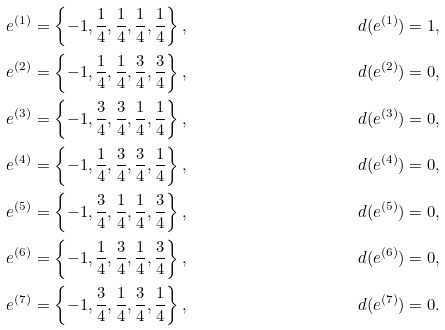<formula> <loc_0><loc_0><loc_500><loc_500>e ^ { ( 1 ) } & = \left \{ - 1 , \frac { 1 } { 4 } , \frac { 1 } { 4 } , \frac { 1 } { 4 } , \frac { 1 } { 4 } \right \} , & d ( e ^ { ( 1 ) } ) = 1 , & & \\ e ^ { ( 2 ) } & = \left \{ - 1 , \frac { 1 } { 4 } , \frac { 1 } { 4 } , \frac { 3 } { 4 } , \frac { 3 } { 4 } \right \} , & d ( e ^ { ( 2 ) } ) = 0 , & & \\ e ^ { ( 3 ) } & = \left \{ - 1 , \frac { 3 } { 4 } , \frac { 3 } { 4 } , \frac { 1 } { 4 } , \frac { 1 } { 4 } \right \} , & d ( e ^ { ( 3 ) } ) = 0 , & & \\ e ^ { ( 4 ) } & = \left \{ - 1 , \frac { 1 } { 4 } , \frac { 3 } { 4 } , \frac { 3 } { 4 } , \frac { 1 } { 4 } \right \} , & d ( e ^ { ( 4 ) } ) = 0 , & & \\ e ^ { ( 5 ) } & = \left \{ - 1 , \frac { 3 } { 4 } , \frac { 1 } { 4 } , \frac { 1 } { 4 } , \frac { 3 } { 4 } \right \} , & d ( e ^ { ( 5 ) } ) = 0 , & & \\ e ^ { ( 6 ) } & = \left \{ - 1 , \frac { 1 } { 4 } , \frac { 3 } { 4 } , \frac { 1 } { 4 } , \frac { 3 } { 4 } \right \} , & d ( e ^ { ( 6 ) } ) = 0 , & & \\ e ^ { ( 7 ) } & = \left \{ - 1 , \frac { 3 } { 4 } , \frac { 1 } { 4 } , \frac { 3 } { 4 } , \frac { 1 } { 4 } \right \} , & d ( e ^ { ( 7 ) } ) = 0 .</formula> 